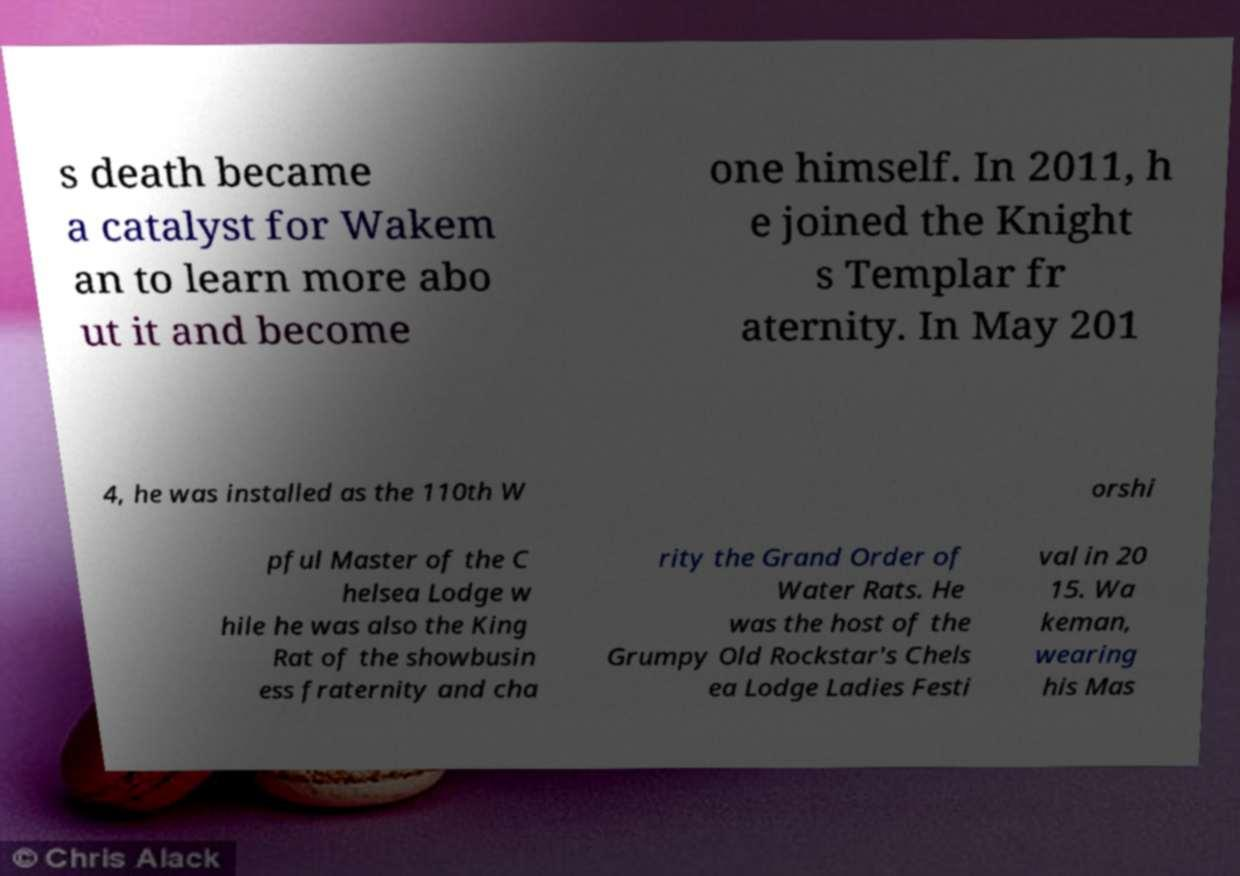Can you accurately transcribe the text from the provided image for me? s death became a catalyst for Wakem an to learn more abo ut it and become one himself. In 2011, h e joined the Knight s Templar fr aternity. In May 201 4, he was installed as the 110th W orshi pful Master of the C helsea Lodge w hile he was also the King Rat of the showbusin ess fraternity and cha rity the Grand Order of Water Rats. He was the host of the Grumpy Old Rockstar's Chels ea Lodge Ladies Festi val in 20 15. Wa keman, wearing his Mas 